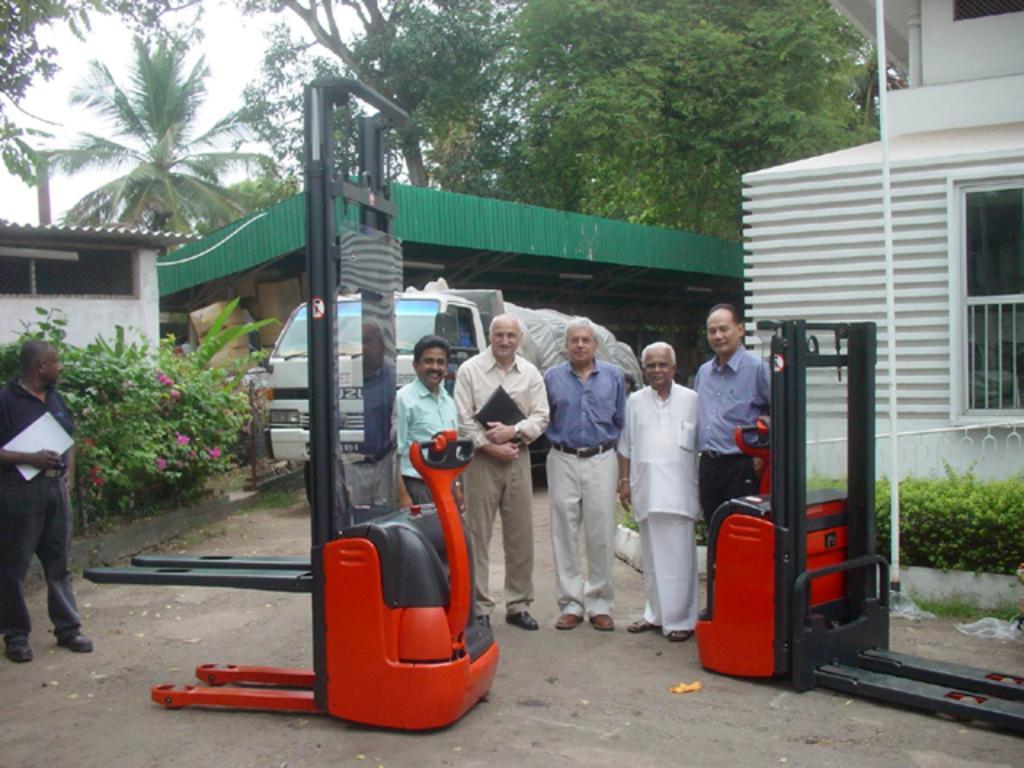Could you give a brief overview of what you see in this image? In this picture there is an old man who is wearing shirt, trouser and shoe. He is holding a black file. Beside him there is another man who is the wearing blue shirt, trouser and shoe. Next to him I can see old man who is wearing white dress. Next to him there is a man who is standing near to the lifting machine. Beside the lifting machine I can see another man who is wearing a shirt and trouser. On the left there is a man who is wearing black dress, shoe and holding the papers. Behind him I can see some flowers on the plants. In the back there is a truck which is parked near to the shed. On the right there is a building. In the background I can see many trees. In the top left there is a sky. 